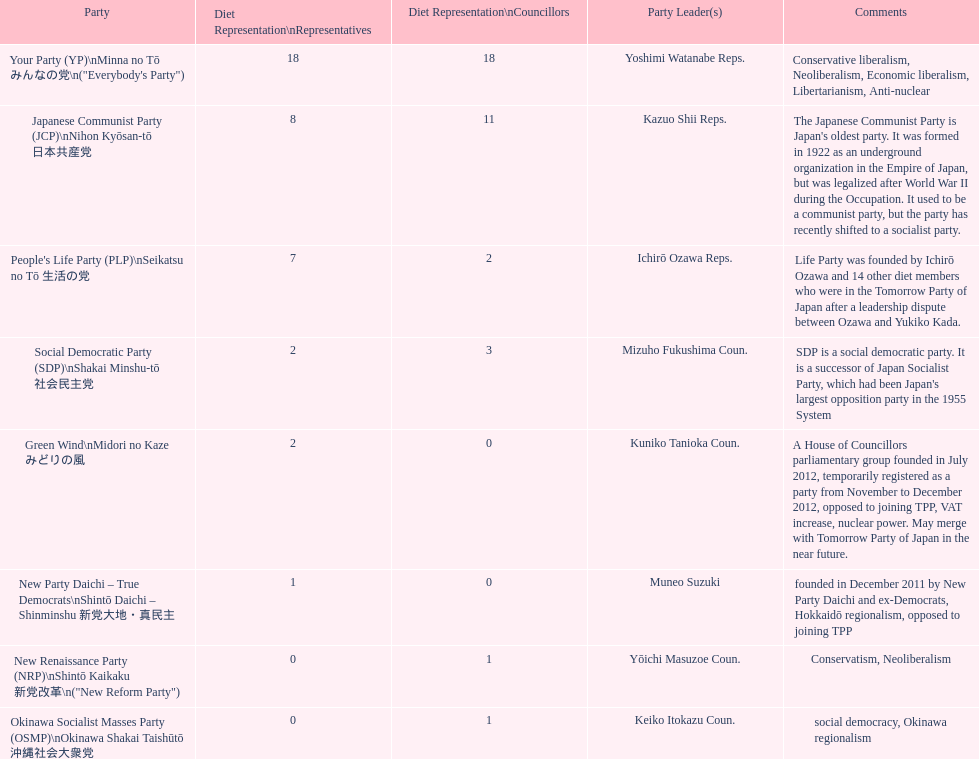How many of these parties currently have no councillors? 2. 